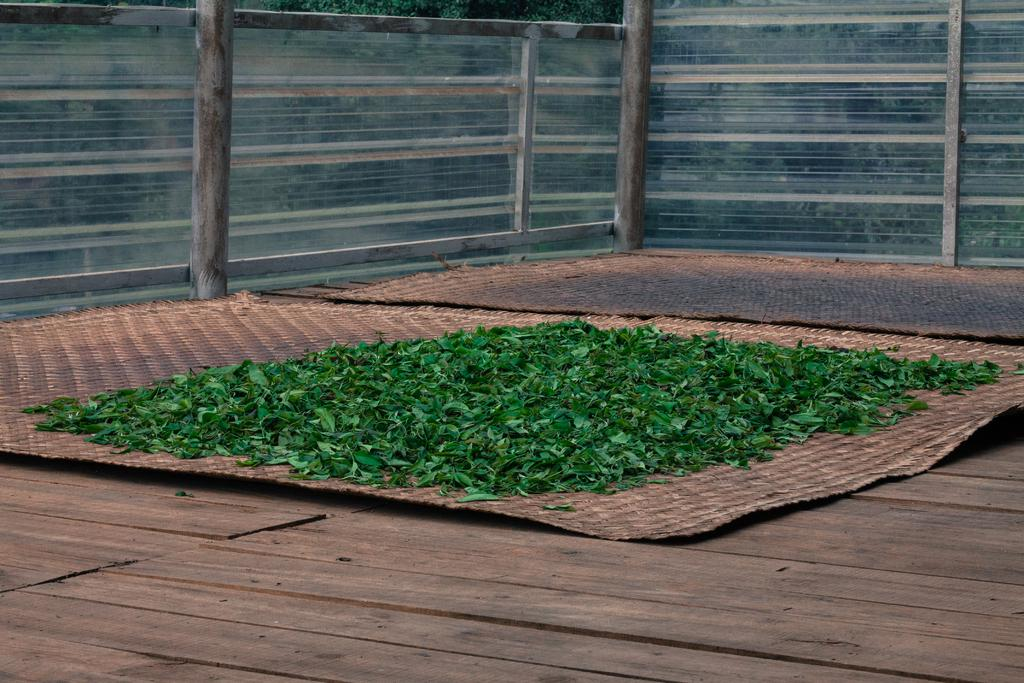What is placed on the mat in the image? There are leaves on a mat in the image. What is the mat resting on? The mat is on a wooden platform. What can be seen in the background of the image? There is a glass fence in the background of the image. How is the glass fence supported? The glass fence is supported by metal rods. What type of map is visible on the wooden platform in the image? There is no map present in the image; it features a mat with leaves on it, a wooden platform, and a glass fence in the background. 